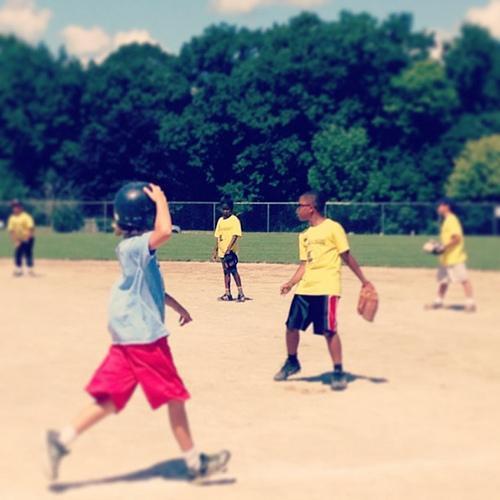How many people can be seen?
Give a very brief answer. 5. How many people are wearing yellow shirts?
Give a very brief answer. 4. 